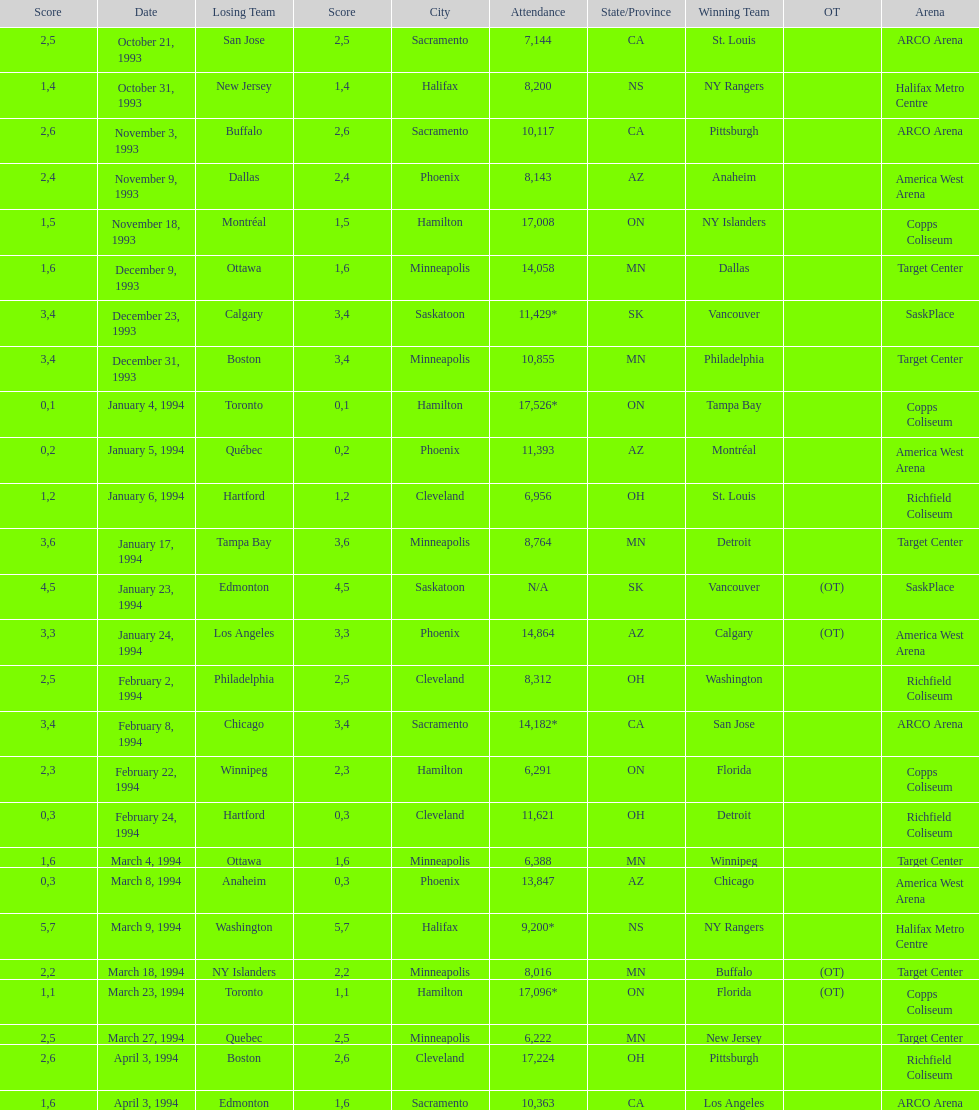How many events occurred in minneapolis, mn? 6. Would you mind parsing the complete table? {'header': ['Score', 'Date', 'Losing Team', 'Score', 'City', 'Attendance', 'State/Province', 'Winning Team', 'OT', 'Arena'], 'rows': [['2', 'October 21, 1993', 'San Jose', '5', 'Sacramento', '7,144', 'CA', 'St. Louis', '', 'ARCO Arena'], ['1', 'October 31, 1993', 'New Jersey', '4', 'Halifax', '8,200', 'NS', 'NY Rangers', '', 'Halifax Metro Centre'], ['2', 'November 3, 1993', 'Buffalo', '6', 'Sacramento', '10,117', 'CA', 'Pittsburgh', '', 'ARCO Arena'], ['2', 'November 9, 1993', 'Dallas', '4', 'Phoenix', '8,143', 'AZ', 'Anaheim', '', 'America West Arena'], ['1', 'November 18, 1993', 'Montréal', '5', 'Hamilton', '17,008', 'ON', 'NY Islanders', '', 'Copps Coliseum'], ['1', 'December 9, 1993', 'Ottawa', '6', 'Minneapolis', '14,058', 'MN', 'Dallas', '', 'Target Center'], ['3', 'December 23, 1993', 'Calgary', '4', 'Saskatoon', '11,429*', 'SK', 'Vancouver', '', 'SaskPlace'], ['3', 'December 31, 1993', 'Boston', '4', 'Minneapolis', '10,855', 'MN', 'Philadelphia', '', 'Target Center'], ['0', 'January 4, 1994', 'Toronto', '1', 'Hamilton', '17,526*', 'ON', 'Tampa Bay', '', 'Copps Coliseum'], ['0', 'January 5, 1994', 'Québec', '2', 'Phoenix', '11,393', 'AZ', 'Montréal', '', 'America West Arena'], ['1', 'January 6, 1994', 'Hartford', '2', 'Cleveland', '6,956', 'OH', 'St. Louis', '', 'Richfield Coliseum'], ['3', 'January 17, 1994', 'Tampa Bay', '6', 'Minneapolis', '8,764', 'MN', 'Detroit', '', 'Target Center'], ['4', 'January 23, 1994', 'Edmonton', '5', 'Saskatoon', 'N/A', 'SK', 'Vancouver', '(OT)', 'SaskPlace'], ['3', 'January 24, 1994', 'Los Angeles', '3', 'Phoenix', '14,864', 'AZ', 'Calgary', '(OT)', 'America West Arena'], ['2', 'February 2, 1994', 'Philadelphia', '5', 'Cleveland', '8,312', 'OH', 'Washington', '', 'Richfield Coliseum'], ['3', 'February 8, 1994', 'Chicago', '4', 'Sacramento', '14,182*', 'CA', 'San Jose', '', 'ARCO Arena'], ['2', 'February 22, 1994', 'Winnipeg', '3', 'Hamilton', '6,291', 'ON', 'Florida', '', 'Copps Coliseum'], ['0', 'February 24, 1994', 'Hartford', '3', 'Cleveland', '11,621', 'OH', 'Detroit', '', 'Richfield Coliseum'], ['1', 'March 4, 1994', 'Ottawa', '6', 'Minneapolis', '6,388', 'MN', 'Winnipeg', '', 'Target Center'], ['0', 'March 8, 1994', 'Anaheim', '3', 'Phoenix', '13,847', 'AZ', 'Chicago', '', 'America West Arena'], ['5', 'March 9, 1994', 'Washington', '7', 'Halifax', '9,200*', 'NS', 'NY Rangers', '', 'Halifax Metro Centre'], ['2', 'March 18, 1994', 'NY Islanders', '2', 'Minneapolis', '8,016', 'MN', 'Buffalo', '(OT)', 'Target Center'], ['1', 'March 23, 1994', 'Toronto', '1', 'Hamilton', '17,096*', 'ON', 'Florida', '(OT)', 'Copps Coliseum'], ['2', 'March 27, 1994', 'Quebec', '5', 'Minneapolis', '6,222', 'MN', 'New Jersey', '', 'Target Center'], ['2', 'April 3, 1994', 'Boston', '6', 'Cleveland', '17,224', 'OH', 'Pittsburgh', '', 'Richfield Coliseum'], ['1', 'April 3, 1994', 'Edmonton', '6', 'Sacramento', '10,363', 'CA', 'Los Angeles', '', 'ARCO Arena']]} 